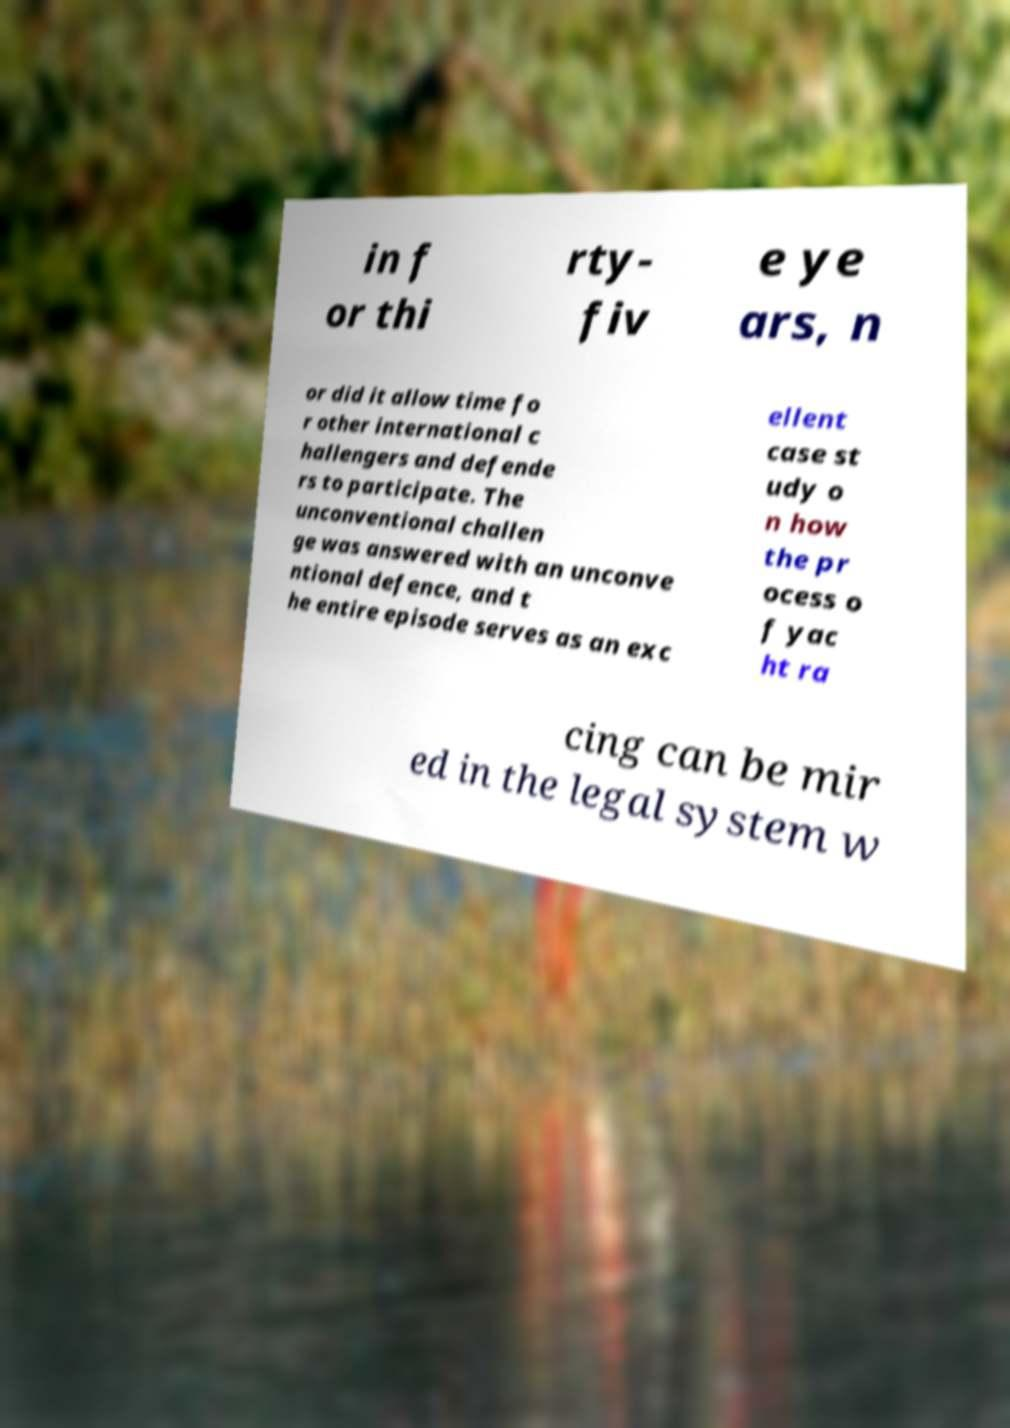Could you extract and type out the text from this image? in f or thi rty- fiv e ye ars, n or did it allow time fo r other international c hallengers and defende rs to participate. The unconventional challen ge was answered with an unconve ntional defence, and t he entire episode serves as an exc ellent case st udy o n how the pr ocess o f yac ht ra cing can be mir ed in the legal system w 